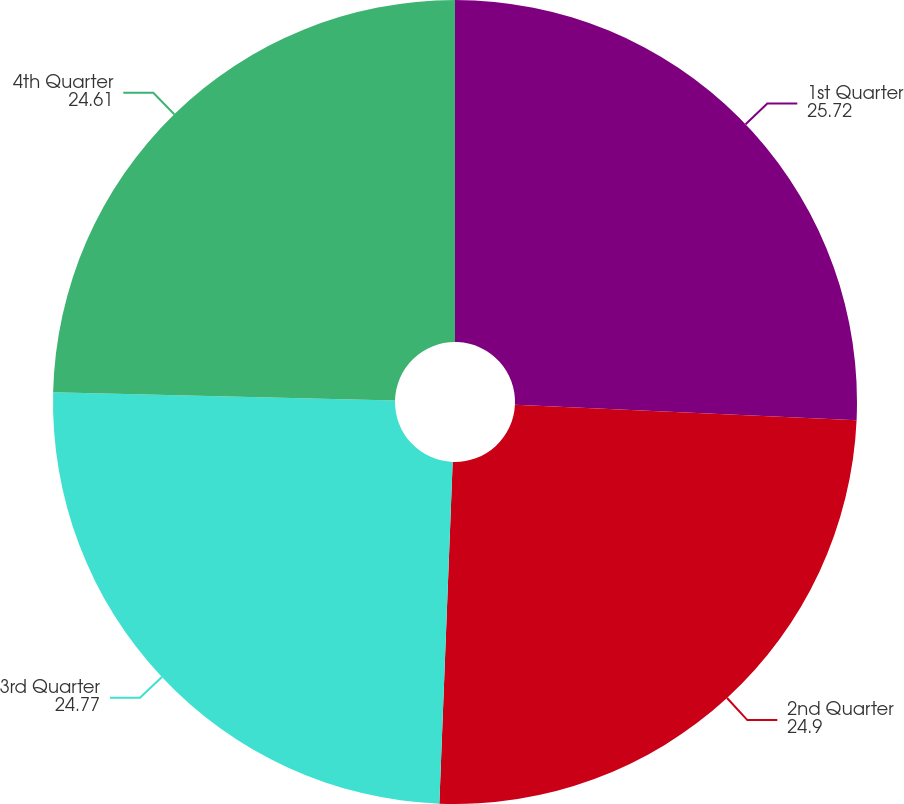Convert chart. <chart><loc_0><loc_0><loc_500><loc_500><pie_chart><fcel>1st Quarter<fcel>2nd Quarter<fcel>3rd Quarter<fcel>4th Quarter<nl><fcel>25.72%<fcel>24.9%<fcel>24.77%<fcel>24.61%<nl></chart> 